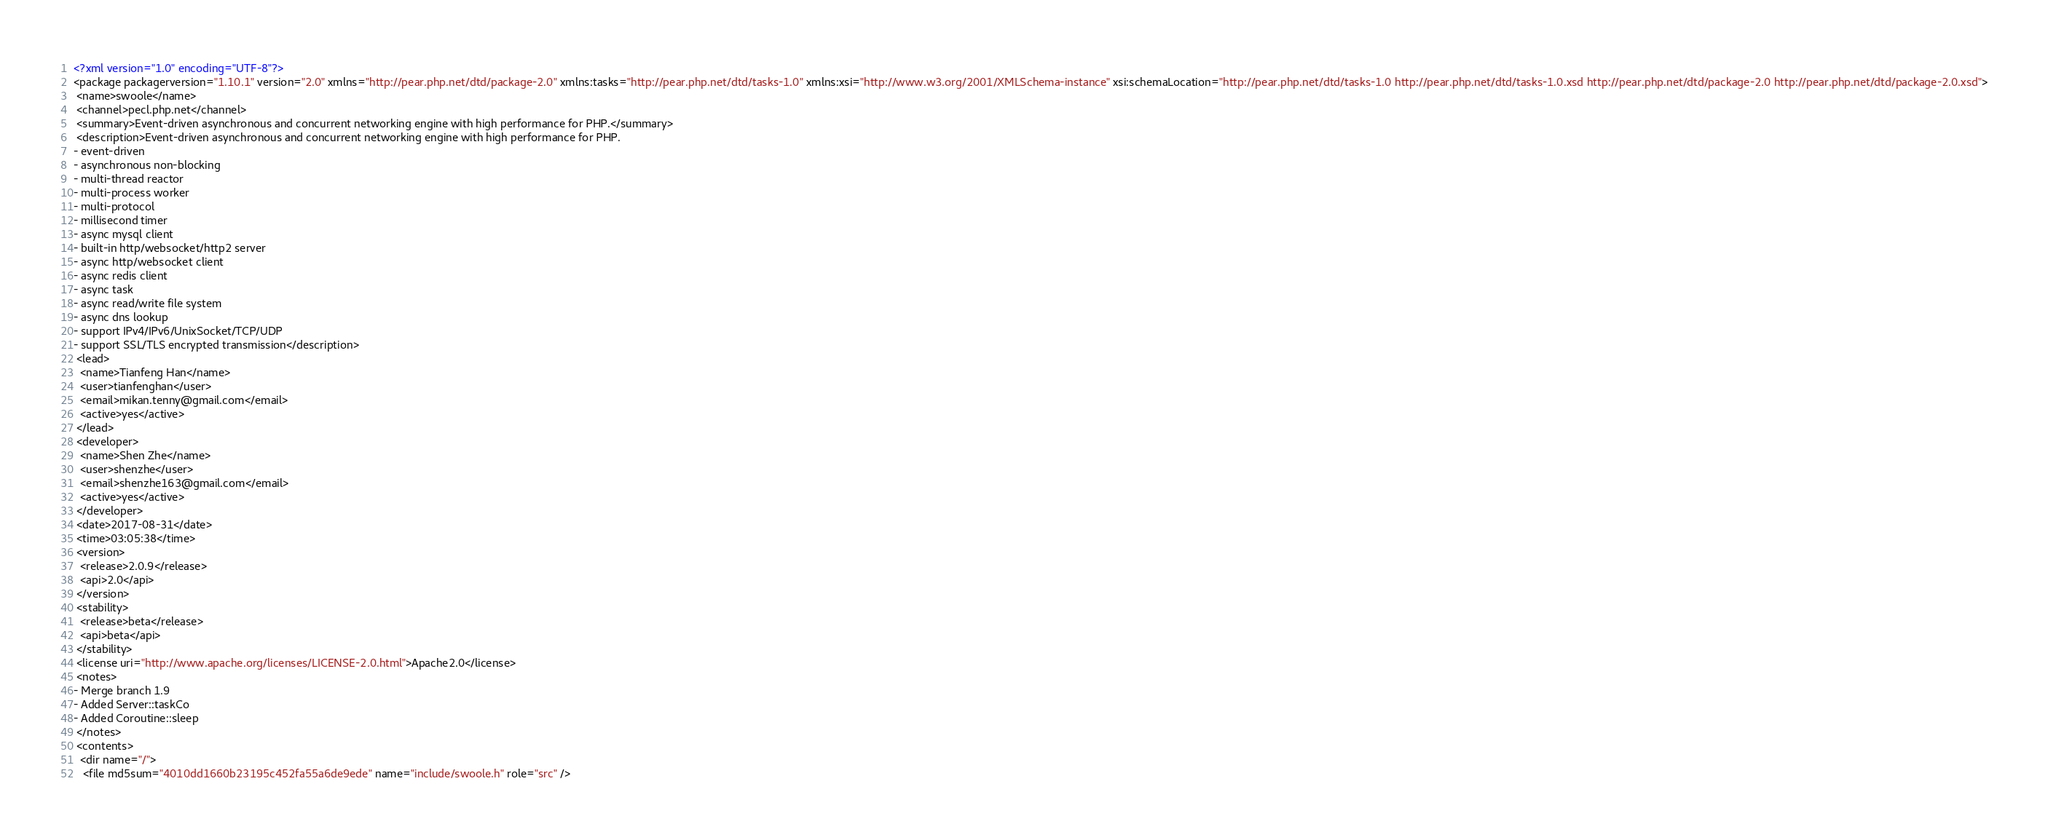<code> <loc_0><loc_0><loc_500><loc_500><_XML_><?xml version="1.0" encoding="UTF-8"?>
<package packagerversion="1.10.1" version="2.0" xmlns="http://pear.php.net/dtd/package-2.0" xmlns:tasks="http://pear.php.net/dtd/tasks-1.0" xmlns:xsi="http://www.w3.org/2001/XMLSchema-instance" xsi:schemaLocation="http://pear.php.net/dtd/tasks-1.0 http://pear.php.net/dtd/tasks-1.0.xsd http://pear.php.net/dtd/package-2.0 http://pear.php.net/dtd/package-2.0.xsd">
 <name>swoole</name>
 <channel>pecl.php.net</channel>
 <summary>Event-driven asynchronous and concurrent networking engine with high performance for PHP.</summary>
 <description>Event-driven asynchronous and concurrent networking engine with high performance for PHP.
- event-driven
- asynchronous non-blocking
- multi-thread reactor
- multi-process worker
- multi-protocol
- millisecond timer
- async mysql client
- built-in http/websocket/http2 server
- async http/websocket client
- async redis client
- async task
- async read/write file system
- async dns lookup
- support IPv4/IPv6/UnixSocket/TCP/UDP
- support SSL/TLS encrypted transmission</description>
 <lead>
  <name>Tianfeng Han</name>
  <user>tianfenghan</user>
  <email>mikan.tenny@gmail.com</email>
  <active>yes</active>
 </lead>
 <developer>
  <name>Shen Zhe</name>
  <user>shenzhe</user>
  <email>shenzhe163@gmail.com</email>
  <active>yes</active>
 </developer>
 <date>2017-08-31</date>
 <time>03:05:38</time>
 <version>
  <release>2.0.9</release>
  <api>2.0</api>
 </version>
 <stability>
  <release>beta</release>
  <api>beta</api>
 </stability>
 <license uri="http://www.apache.org/licenses/LICENSE-2.0.html">Apache2.0</license>
 <notes>
- Merge branch 1.9
- Added Server::taskCo
- Added Coroutine::sleep
 </notes>
 <contents>
  <dir name="/">
   <file md5sum="4010dd1660b23195c452fa55a6de9ede" name="include/swoole.h" role="src" /></code> 